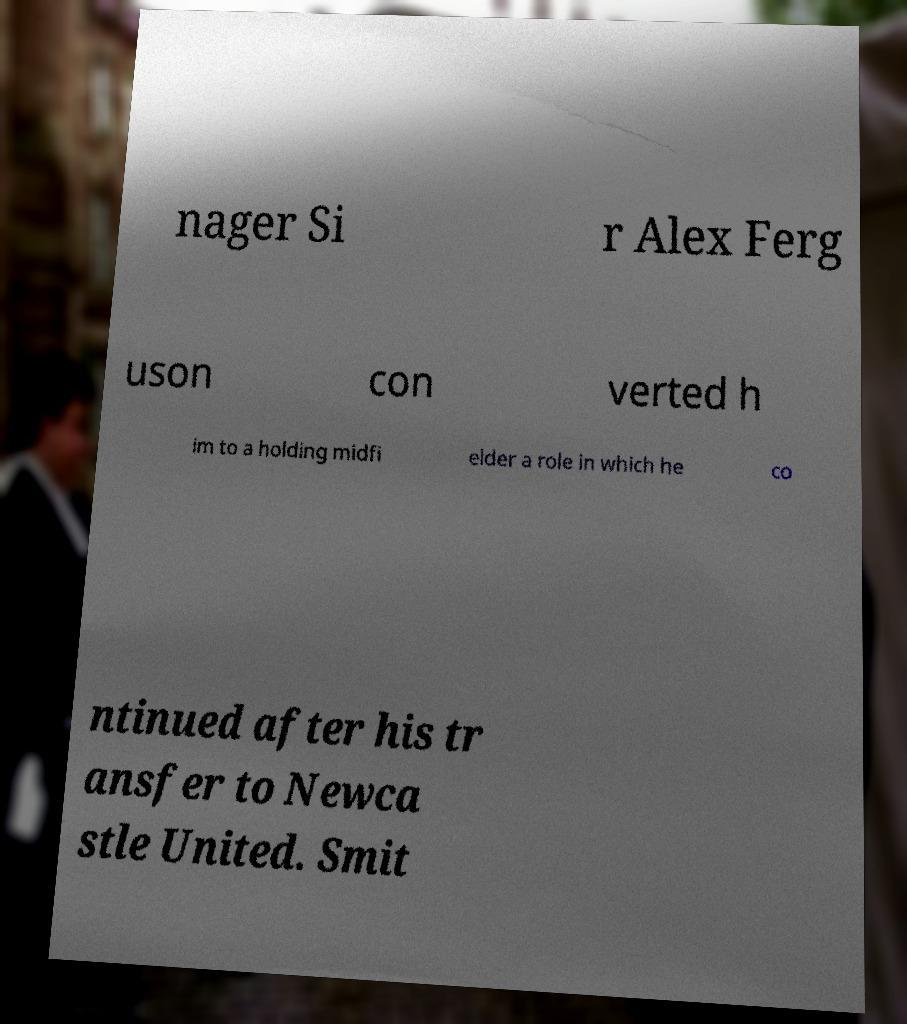I need the written content from this picture converted into text. Can you do that? nager Si r Alex Ferg uson con verted h im to a holding midfi elder a role in which he co ntinued after his tr ansfer to Newca stle United. Smit 